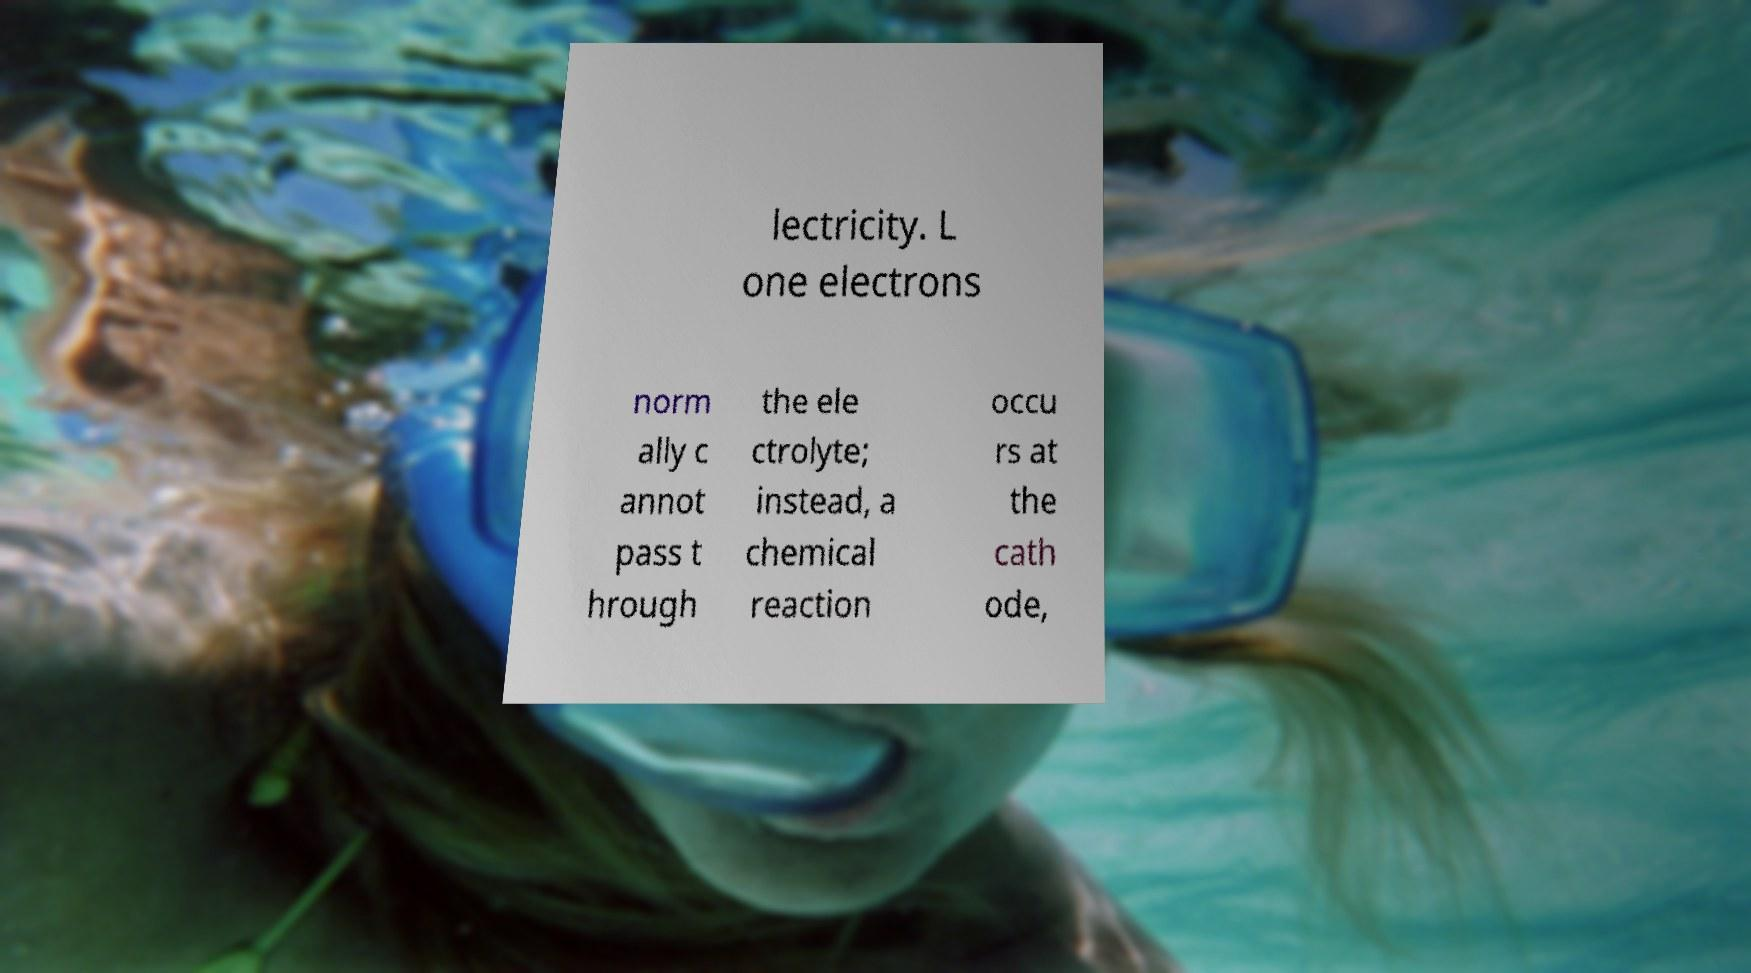Could you extract and type out the text from this image? lectricity. L one electrons norm ally c annot pass t hrough the ele ctrolyte; instead, a chemical reaction occu rs at the cath ode, 